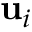<formula> <loc_0><loc_0><loc_500><loc_500>u _ { i }</formula> 